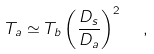Convert formula to latex. <formula><loc_0><loc_0><loc_500><loc_500>T _ { a } \simeq T _ { b } \left ( \frac { D _ { s } } { D _ { a } } \right ) ^ { 2 } \ \ ,</formula> 